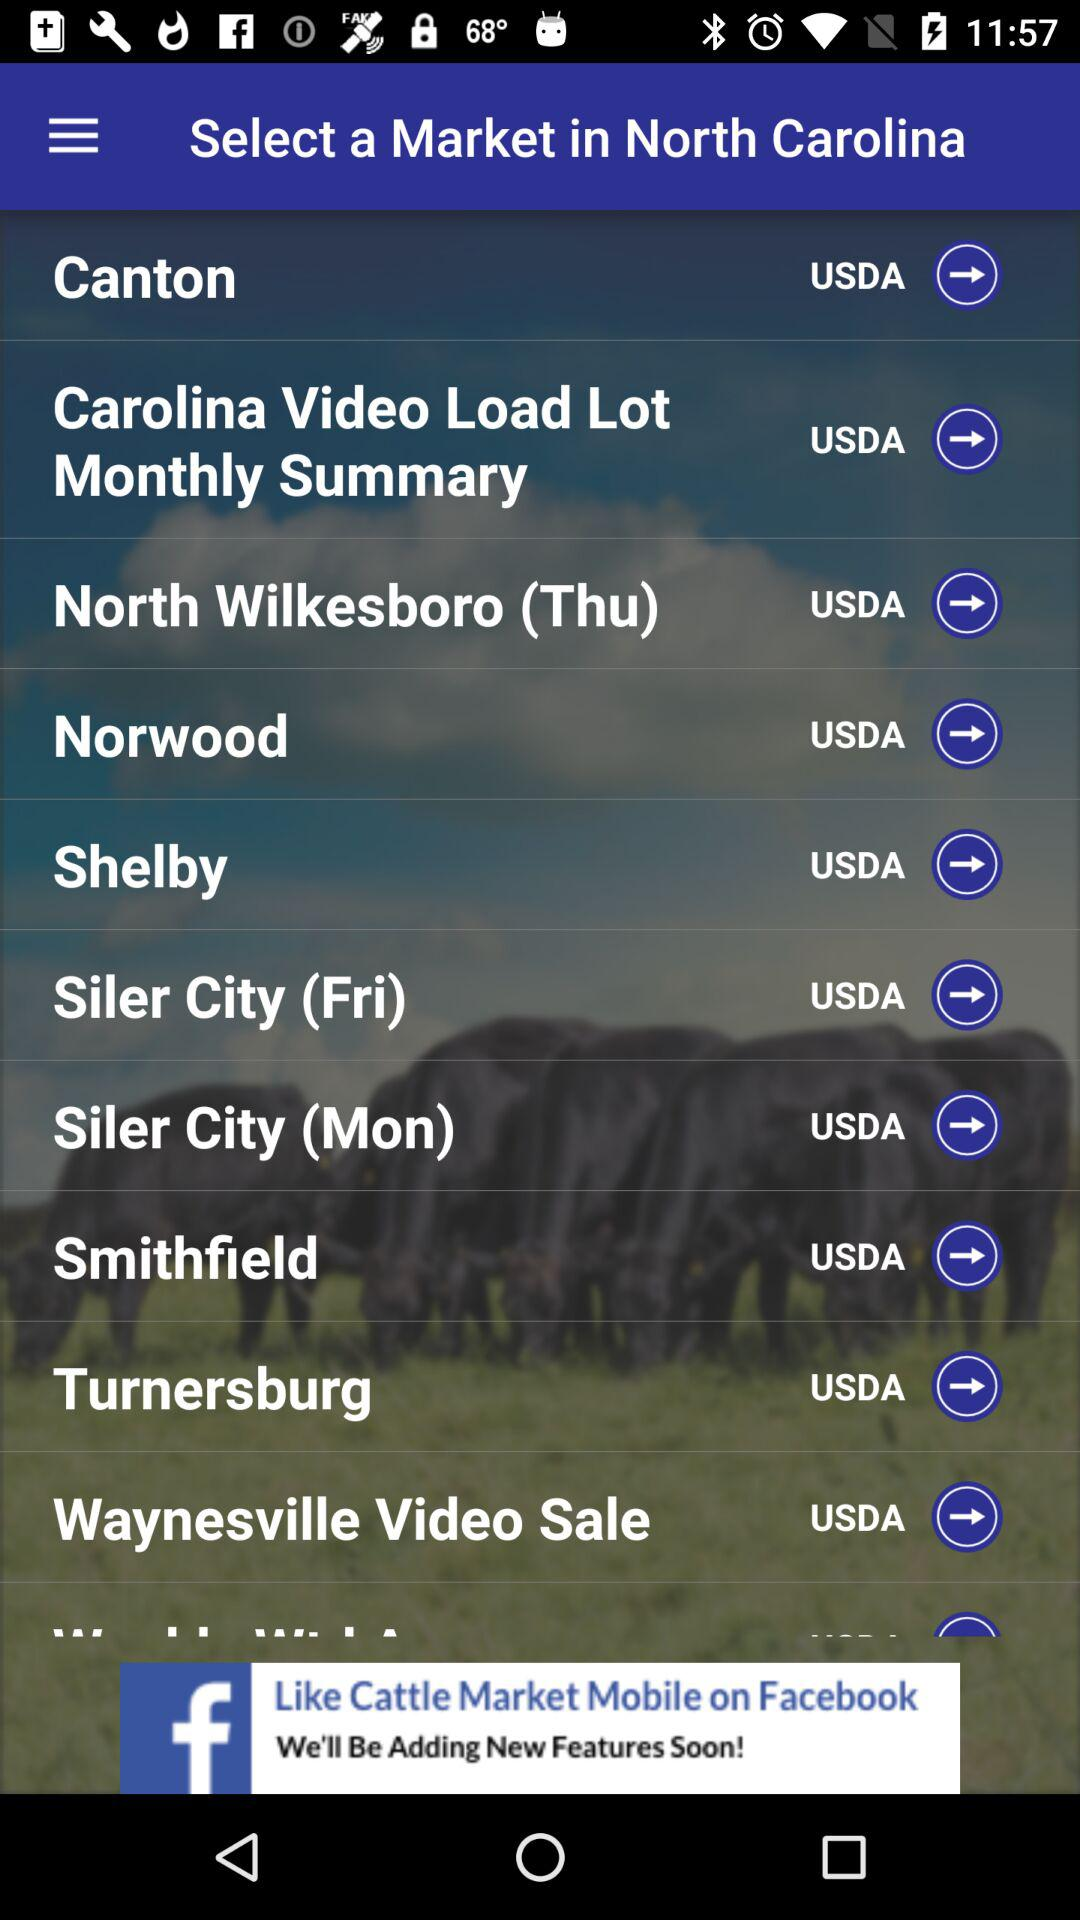Which are the market options that I can select in North Carolina? The options are "Canton", "Carolina Video Load Lot Monthly Summary", "North Wilkesboro (Thu)", "Norwood", "Shelby", "Siler City (Fri)", "Siler City (Mon)", "Smithfield", "Turnersburg" and "Waynesville Video Sale". 